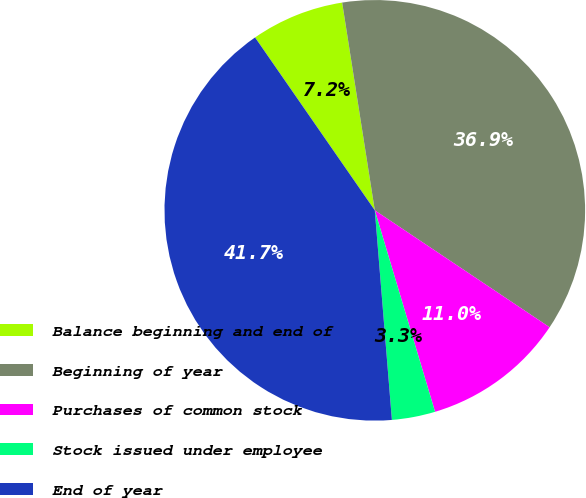<chart> <loc_0><loc_0><loc_500><loc_500><pie_chart><fcel>Balance beginning and end of<fcel>Beginning of year<fcel>Purchases of common stock<fcel>Stock issued under employee<fcel>End of year<nl><fcel>7.16%<fcel>36.86%<fcel>10.99%<fcel>3.33%<fcel>41.65%<nl></chart> 